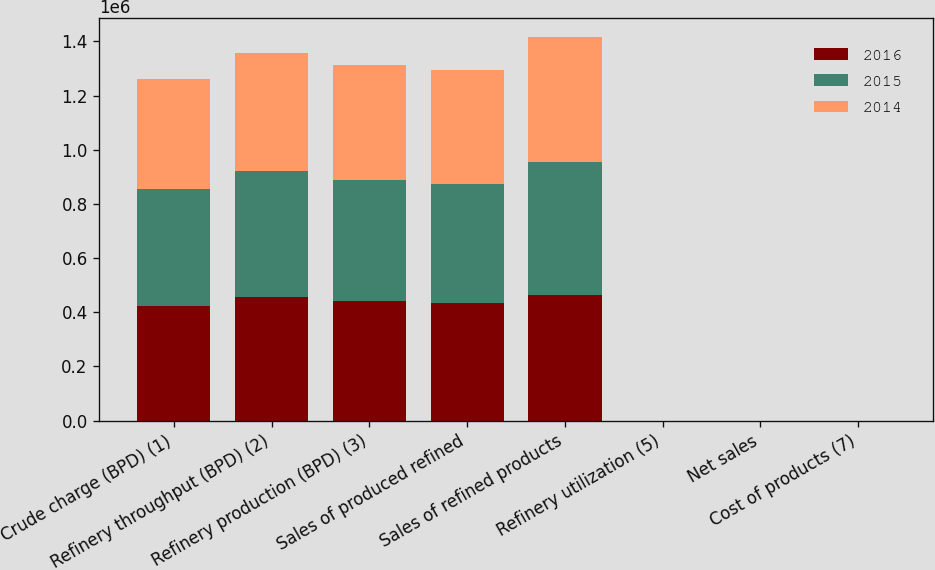Convert chart to OTSL. <chart><loc_0><loc_0><loc_500><loc_500><stacked_bar_chart><ecel><fcel>Crude charge (BPD) (1)<fcel>Refinery throughput (BPD) (2)<fcel>Refinery production (BPD) (3)<fcel>Sales of produced refined<fcel>Sales of refined products<fcel>Refinery utilization (5)<fcel>Net sales<fcel>Cost of products (7)<nl><fcel>2016<fcel>423910<fcel>457480<fcel>442110<fcel>435420<fcel>464980<fcel>92.8<fcel>58.02<fcel>49.64<nl><fcel>2015<fcel>432560<fcel>463580<fcel>446560<fcel>438000<fcel>488350<fcel>97.6<fcel>71.32<fcel>55.25<nl><fcel>2014<fcel>406180<fcel>436400<fcel>425010<fcel>420990<fcel>461640<fcel>91.7<fcel>110.19<fcel>96.21<nl></chart> 